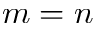Convert formula to latex. <formula><loc_0><loc_0><loc_500><loc_500>m = n</formula> 